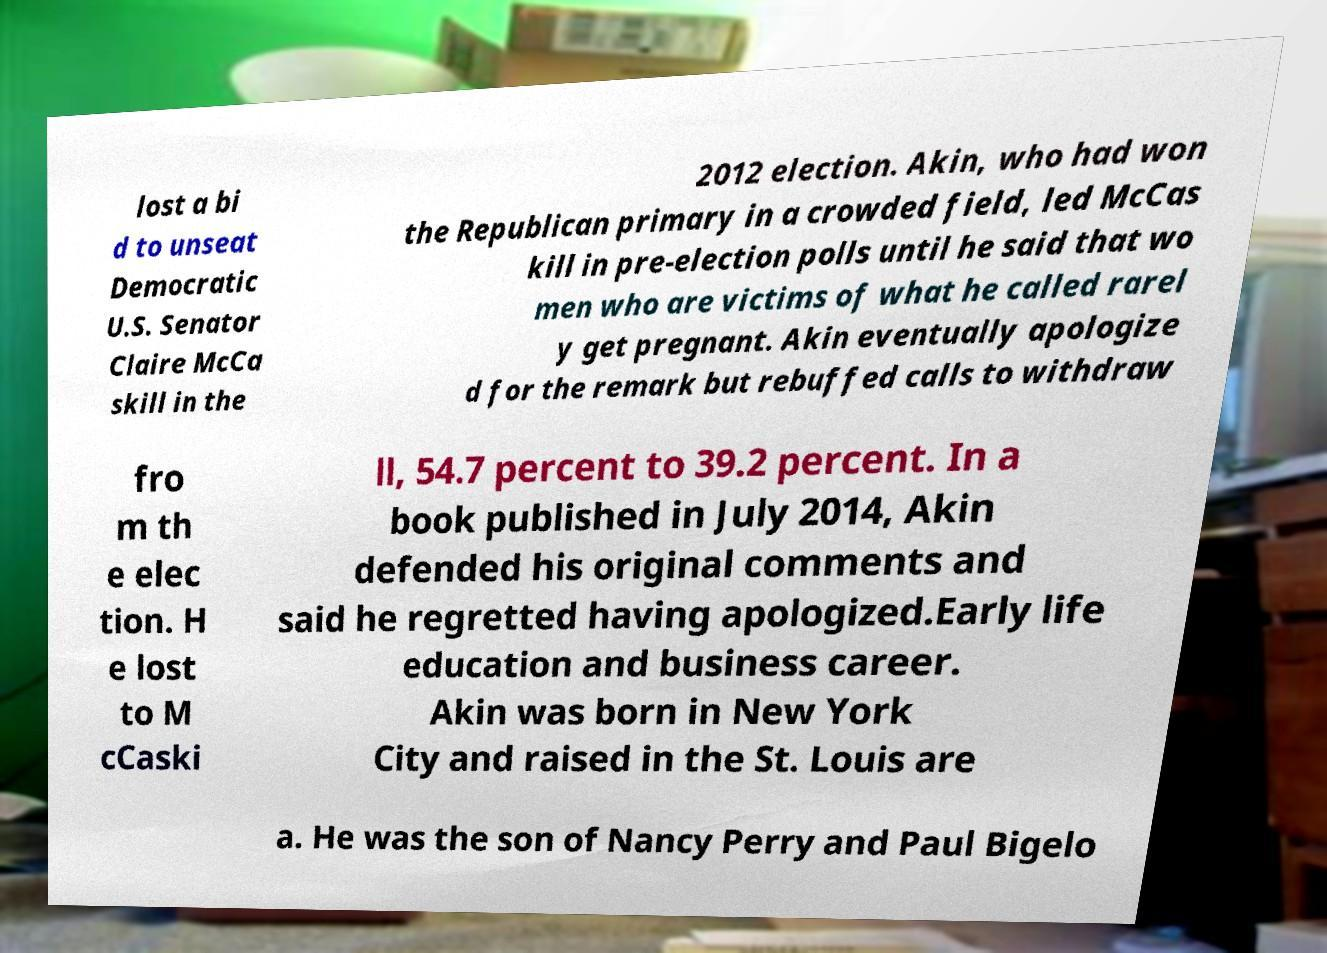There's text embedded in this image that I need extracted. Can you transcribe it verbatim? lost a bi d to unseat Democratic U.S. Senator Claire McCa skill in the 2012 election. Akin, who had won the Republican primary in a crowded field, led McCas kill in pre-election polls until he said that wo men who are victims of what he called rarel y get pregnant. Akin eventually apologize d for the remark but rebuffed calls to withdraw fro m th e elec tion. H e lost to M cCaski ll, 54.7 percent to 39.2 percent. In a book published in July 2014, Akin defended his original comments and said he regretted having apologized.Early life education and business career. Akin was born in New York City and raised in the St. Louis are a. He was the son of Nancy Perry and Paul Bigelo 